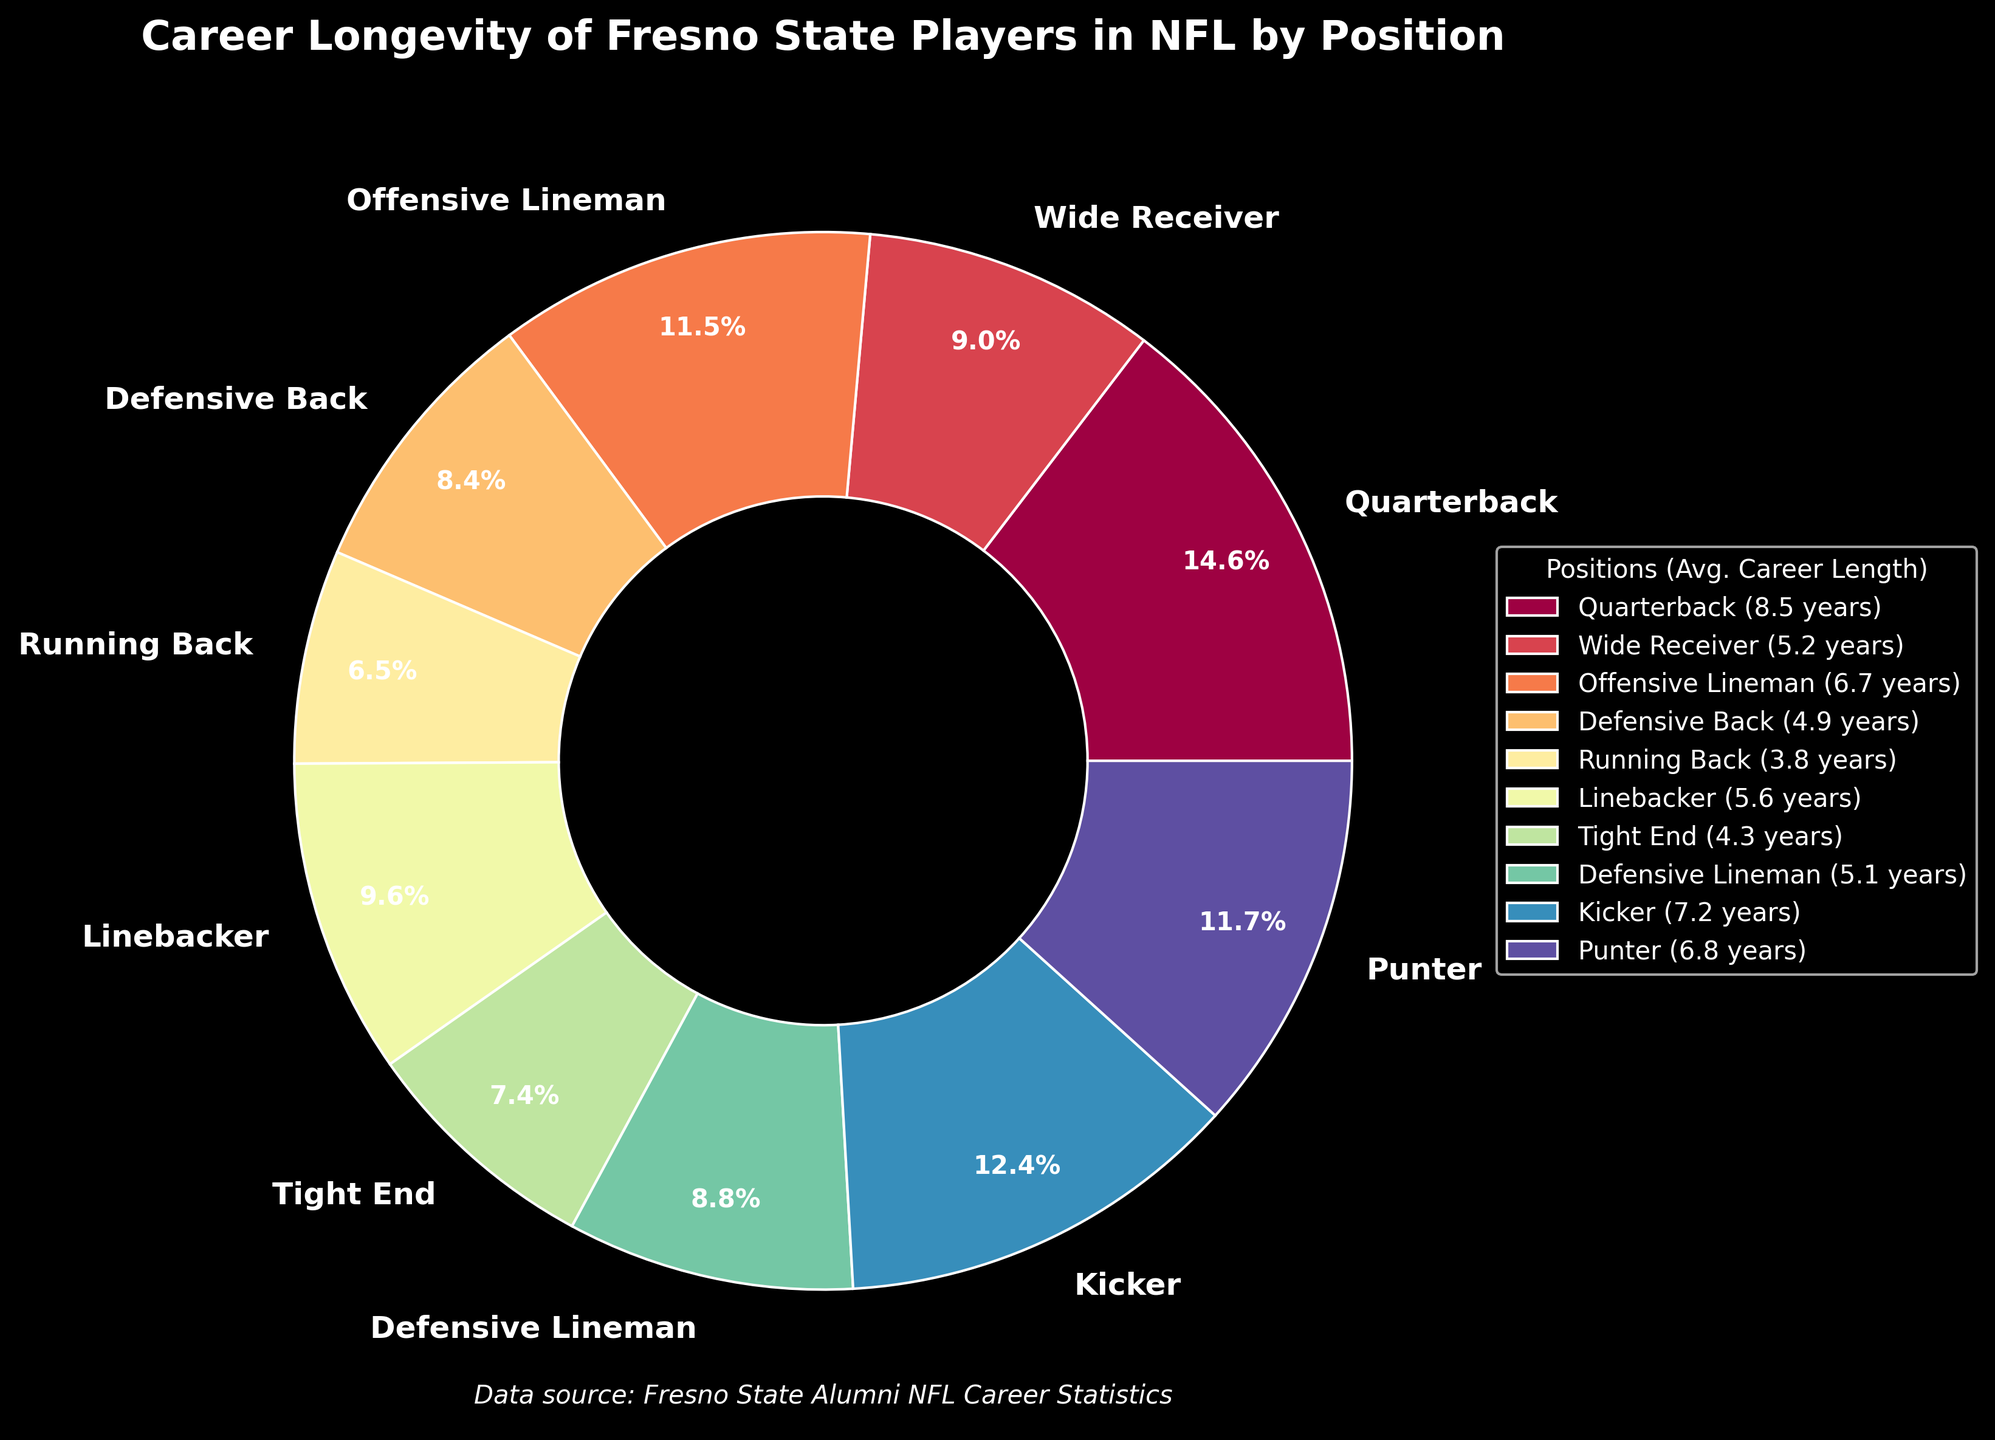What's the position with the longest average career length? From the pie chart, look for the position with the largest percentage slice labeled with the highest number of years. This position should be easy to identify visually.
Answer: Quarterback Which positions have an average career length less than 5 years? Identify the slices that represent less than 5 years and list their positions. Look for percentages that correspond to lower numbers and match them with the labels.
Answer: Defensive Back, Running Back, Tight End How much longer, on average, do kickers last in the NFL compared to running backs? Find the average career lengths of kickers and running backs from the pie chart. Subtract the career length of running backs from that of kickers (7.2 years - 3.8 years).
Answer: 3.4 years What is the sum of the average career lengths for wide receivers and linebackers? Locate the average career lengths of wide receivers and linebackers. Add the two values together (5.2 years + 5.6 years).
Answer: 10.8 years What proportion of the carousel relates to offensive linemen and punters combined? Find the percentage slices for offensive linemen and punters. Add these percentages together to get the combined proportion. Since precise percentages are not given, if approximations aren't visible, refer to their average lengths and sum them.
Answer: Approximately 12.3% Which two positions have the smallest difference in their average career lengths? Identify the positions with close average career lengths values on the pie chart. Calculate the differences and find the smallest one. The pairs could be evaluated by looking at the labeled numbers on the wedges.
Answer: Defensive Lineman and Defensive Back Out of all positions listed, how many have an average career length of 5 years or more? Count the slices that represent an average career length of at least 5 years by reading the values associated with each position.
Answer: 5 If you combine the career lengths of quarterbacks, punters, and kickers, does this surpass the total of offensive linemen and tight ends? Add the career lengths of quarterbacks, punters, and kickers (8.5 + 6.8 + 7.2). Compare this sum to the combined lengths of offensive linemen and tight ends (6.7 + 4.3).
Answer: Yes 